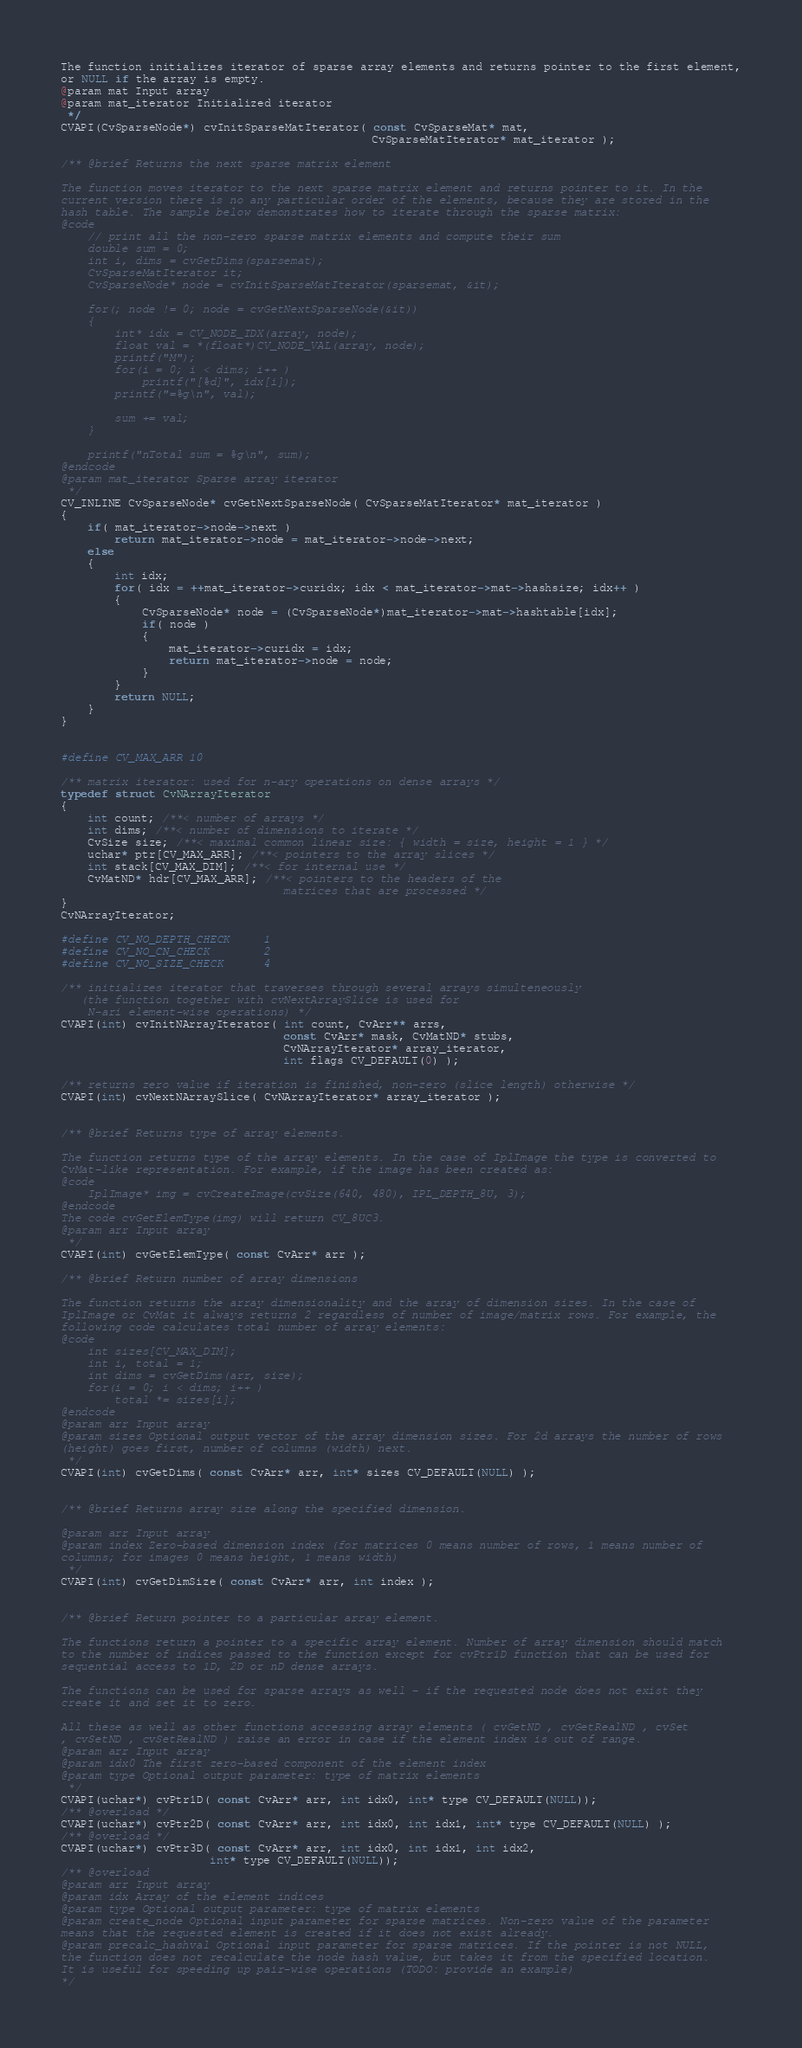Convert code to text. <code><loc_0><loc_0><loc_500><loc_500><_C_>
The function initializes iterator of sparse array elements and returns pointer to the first element,
or NULL if the array is empty.
@param mat Input array
@param mat_iterator Initialized iterator
 */
CVAPI(CvSparseNode*) cvInitSparseMatIterator( const CvSparseMat* mat,
                                              CvSparseMatIterator* mat_iterator );

/** @brief Returns the next sparse matrix element

The function moves iterator to the next sparse matrix element and returns pointer to it. In the
current version there is no any particular order of the elements, because they are stored in the
hash table. The sample below demonstrates how to iterate through the sparse matrix:
@code
    // print all the non-zero sparse matrix elements and compute their sum
    double sum = 0;
    int i, dims = cvGetDims(sparsemat);
    CvSparseMatIterator it;
    CvSparseNode* node = cvInitSparseMatIterator(sparsemat, &it);

    for(; node != 0; node = cvGetNextSparseNode(&it))
    {
        int* idx = CV_NODE_IDX(array, node);
        float val = *(float*)CV_NODE_VAL(array, node);
        printf("M");
        for(i = 0; i < dims; i++ )
            printf("[%d]", idx[i]);
        printf("=%g\n", val);

        sum += val;
    }

    printf("nTotal sum = %g\n", sum);
@endcode
@param mat_iterator Sparse array iterator
 */
CV_INLINE CvSparseNode* cvGetNextSparseNode( CvSparseMatIterator* mat_iterator )
{
    if( mat_iterator->node->next )
        return mat_iterator->node = mat_iterator->node->next;
    else
    {
        int idx;
        for( idx = ++mat_iterator->curidx; idx < mat_iterator->mat->hashsize; idx++ )
        {
            CvSparseNode* node = (CvSparseNode*)mat_iterator->mat->hashtable[idx];
            if( node )
            {
                mat_iterator->curidx = idx;
                return mat_iterator->node = node;
            }
        }
        return NULL;
    }
}


#define CV_MAX_ARR 10

/** matrix iterator: used for n-ary operations on dense arrays */
typedef struct CvNArrayIterator
{
    int count; /**< number of arrays */
    int dims; /**< number of dimensions to iterate */
    CvSize size; /**< maximal common linear size: { width = size, height = 1 } */
    uchar* ptr[CV_MAX_ARR]; /**< pointers to the array slices */
    int stack[CV_MAX_DIM]; /**< for internal use */
    CvMatND* hdr[CV_MAX_ARR]; /**< pointers to the headers of the
                                 matrices that are processed */
}
CvNArrayIterator;

#define CV_NO_DEPTH_CHECK     1
#define CV_NO_CN_CHECK        2
#define CV_NO_SIZE_CHECK      4

/** initializes iterator that traverses through several arrays simulteneously
   (the function together with cvNextArraySlice is used for
    N-ari element-wise operations) */
CVAPI(int) cvInitNArrayIterator( int count, CvArr** arrs,
                                 const CvArr* mask, CvMatND* stubs,
                                 CvNArrayIterator* array_iterator,
                                 int flags CV_DEFAULT(0) );

/** returns zero value if iteration is finished, non-zero (slice length) otherwise */
CVAPI(int) cvNextNArraySlice( CvNArrayIterator* array_iterator );


/** @brief Returns type of array elements.

The function returns type of the array elements. In the case of IplImage the type is converted to
CvMat-like representation. For example, if the image has been created as:
@code
    IplImage* img = cvCreateImage(cvSize(640, 480), IPL_DEPTH_8U, 3);
@endcode
The code cvGetElemType(img) will return CV_8UC3.
@param arr Input array
 */
CVAPI(int) cvGetElemType( const CvArr* arr );

/** @brief Return number of array dimensions

The function returns the array dimensionality and the array of dimension sizes. In the case of
IplImage or CvMat it always returns 2 regardless of number of image/matrix rows. For example, the
following code calculates total number of array elements:
@code
    int sizes[CV_MAX_DIM];
    int i, total = 1;
    int dims = cvGetDims(arr, size);
    for(i = 0; i < dims; i++ )
        total *= sizes[i];
@endcode
@param arr Input array
@param sizes Optional output vector of the array dimension sizes. For 2d arrays the number of rows
(height) goes first, number of columns (width) next.
 */
CVAPI(int) cvGetDims( const CvArr* arr, int* sizes CV_DEFAULT(NULL) );


/** @brief Returns array size along the specified dimension.

@param arr Input array
@param index Zero-based dimension index (for matrices 0 means number of rows, 1 means number of
columns; for images 0 means height, 1 means width)
 */
CVAPI(int) cvGetDimSize( const CvArr* arr, int index );


/** @brief Return pointer to a particular array element.

The functions return a pointer to a specific array element. Number of array dimension should match
to the number of indices passed to the function except for cvPtr1D function that can be used for
sequential access to 1D, 2D or nD dense arrays.

The functions can be used for sparse arrays as well - if the requested node does not exist they
create it and set it to zero.

All these as well as other functions accessing array elements ( cvGetND , cvGetRealND , cvSet
, cvSetND , cvSetRealND ) raise an error in case if the element index is out of range.
@param arr Input array
@param idx0 The first zero-based component of the element index
@param type Optional output parameter: type of matrix elements
 */
CVAPI(uchar*) cvPtr1D( const CvArr* arr, int idx0, int* type CV_DEFAULT(NULL));
/** @overload */
CVAPI(uchar*) cvPtr2D( const CvArr* arr, int idx0, int idx1, int* type CV_DEFAULT(NULL) );
/** @overload */
CVAPI(uchar*) cvPtr3D( const CvArr* arr, int idx0, int idx1, int idx2,
                      int* type CV_DEFAULT(NULL));
/** @overload
@param arr Input array
@param idx Array of the element indices
@param type Optional output parameter: type of matrix elements
@param create_node Optional input parameter for sparse matrices. Non-zero value of the parameter
means that the requested element is created if it does not exist already.
@param precalc_hashval Optional input parameter for sparse matrices. If the pointer is not NULL,
the function does not recalculate the node hash value, but takes it from the specified location.
It is useful for speeding up pair-wise operations (TODO: provide an example)
*/</code> 